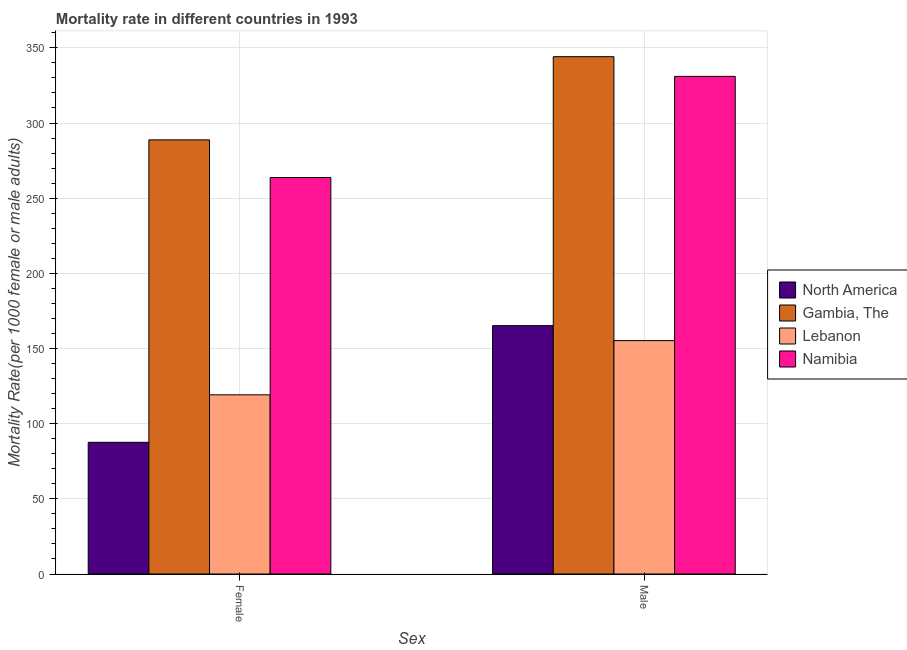How many different coloured bars are there?
Ensure brevity in your answer.  4. How many groups of bars are there?
Offer a terse response. 2. Are the number of bars on each tick of the X-axis equal?
Provide a short and direct response. Yes. How many bars are there on the 1st tick from the left?
Your answer should be very brief. 4. How many bars are there on the 1st tick from the right?
Your response must be concise. 4. What is the label of the 2nd group of bars from the left?
Ensure brevity in your answer.  Male. What is the male mortality rate in North America?
Give a very brief answer. 165.2. Across all countries, what is the maximum female mortality rate?
Provide a short and direct response. 288.79. Across all countries, what is the minimum male mortality rate?
Keep it short and to the point. 155.25. In which country was the female mortality rate maximum?
Give a very brief answer. Gambia, The. In which country was the male mortality rate minimum?
Your answer should be very brief. Lebanon. What is the total male mortality rate in the graph?
Your answer should be very brief. 995.58. What is the difference between the male mortality rate in North America and that in Gambia, The?
Make the answer very short. -178.91. What is the difference between the female mortality rate in Gambia, The and the male mortality rate in Namibia?
Your answer should be very brief. -42.23. What is the average female mortality rate per country?
Ensure brevity in your answer.  189.83. What is the difference between the female mortality rate and male mortality rate in Gambia, The?
Keep it short and to the point. -55.33. In how many countries, is the female mortality rate greater than 350 ?
Ensure brevity in your answer.  0. What is the ratio of the female mortality rate in Lebanon to that in Namibia?
Your response must be concise. 0.45. Is the male mortality rate in Namibia less than that in North America?
Offer a very short reply. No. In how many countries, is the female mortality rate greater than the average female mortality rate taken over all countries?
Your answer should be compact. 2. What does the 3rd bar from the left in Female represents?
Make the answer very short. Lebanon. What does the 1st bar from the right in Female represents?
Offer a very short reply. Namibia. Are all the bars in the graph horizontal?
Offer a very short reply. No. How many countries are there in the graph?
Your response must be concise. 4. What is the difference between two consecutive major ticks on the Y-axis?
Keep it short and to the point. 50. Does the graph contain any zero values?
Ensure brevity in your answer.  No. Does the graph contain grids?
Provide a short and direct response. Yes. What is the title of the graph?
Make the answer very short. Mortality rate in different countries in 1993. What is the label or title of the X-axis?
Provide a short and direct response. Sex. What is the label or title of the Y-axis?
Provide a short and direct response. Mortality Rate(per 1000 female or male adults). What is the Mortality Rate(per 1000 female or male adults) of North America in Female?
Ensure brevity in your answer.  87.6. What is the Mortality Rate(per 1000 female or male adults) of Gambia, The in Female?
Your response must be concise. 288.79. What is the Mortality Rate(per 1000 female or male adults) in Lebanon in Female?
Ensure brevity in your answer.  119.19. What is the Mortality Rate(per 1000 female or male adults) in Namibia in Female?
Make the answer very short. 263.75. What is the Mortality Rate(per 1000 female or male adults) of North America in Male?
Keep it short and to the point. 165.2. What is the Mortality Rate(per 1000 female or male adults) in Gambia, The in Male?
Your answer should be very brief. 344.12. What is the Mortality Rate(per 1000 female or male adults) in Lebanon in Male?
Make the answer very short. 155.25. What is the Mortality Rate(per 1000 female or male adults) in Namibia in Male?
Offer a terse response. 331.02. Across all Sex, what is the maximum Mortality Rate(per 1000 female or male adults) in North America?
Provide a succinct answer. 165.2. Across all Sex, what is the maximum Mortality Rate(per 1000 female or male adults) of Gambia, The?
Your response must be concise. 344.12. Across all Sex, what is the maximum Mortality Rate(per 1000 female or male adults) in Lebanon?
Your answer should be very brief. 155.25. Across all Sex, what is the maximum Mortality Rate(per 1000 female or male adults) in Namibia?
Make the answer very short. 331.02. Across all Sex, what is the minimum Mortality Rate(per 1000 female or male adults) in North America?
Your answer should be compact. 87.6. Across all Sex, what is the minimum Mortality Rate(per 1000 female or male adults) of Gambia, The?
Keep it short and to the point. 288.79. Across all Sex, what is the minimum Mortality Rate(per 1000 female or male adults) in Lebanon?
Your response must be concise. 119.19. Across all Sex, what is the minimum Mortality Rate(per 1000 female or male adults) in Namibia?
Your answer should be compact. 263.75. What is the total Mortality Rate(per 1000 female or male adults) in North America in the graph?
Offer a very short reply. 252.81. What is the total Mortality Rate(per 1000 female or male adults) of Gambia, The in the graph?
Your answer should be compact. 632.9. What is the total Mortality Rate(per 1000 female or male adults) in Lebanon in the graph?
Your answer should be compact. 274.43. What is the total Mortality Rate(per 1000 female or male adults) of Namibia in the graph?
Keep it short and to the point. 594.77. What is the difference between the Mortality Rate(per 1000 female or male adults) of North America in Female and that in Male?
Ensure brevity in your answer.  -77.6. What is the difference between the Mortality Rate(per 1000 female or male adults) in Gambia, The in Female and that in Male?
Offer a very short reply. -55.33. What is the difference between the Mortality Rate(per 1000 female or male adults) of Lebanon in Female and that in Male?
Your response must be concise. -36.06. What is the difference between the Mortality Rate(per 1000 female or male adults) in Namibia in Female and that in Male?
Give a very brief answer. -67.27. What is the difference between the Mortality Rate(per 1000 female or male adults) in North America in Female and the Mortality Rate(per 1000 female or male adults) in Gambia, The in Male?
Provide a short and direct response. -256.51. What is the difference between the Mortality Rate(per 1000 female or male adults) of North America in Female and the Mortality Rate(per 1000 female or male adults) of Lebanon in Male?
Your response must be concise. -67.64. What is the difference between the Mortality Rate(per 1000 female or male adults) of North America in Female and the Mortality Rate(per 1000 female or male adults) of Namibia in Male?
Make the answer very short. -243.42. What is the difference between the Mortality Rate(per 1000 female or male adults) in Gambia, The in Female and the Mortality Rate(per 1000 female or male adults) in Lebanon in Male?
Provide a succinct answer. 133.54. What is the difference between the Mortality Rate(per 1000 female or male adults) in Gambia, The in Female and the Mortality Rate(per 1000 female or male adults) in Namibia in Male?
Provide a succinct answer. -42.23. What is the difference between the Mortality Rate(per 1000 female or male adults) in Lebanon in Female and the Mortality Rate(per 1000 female or male adults) in Namibia in Male?
Give a very brief answer. -211.83. What is the average Mortality Rate(per 1000 female or male adults) of North America per Sex?
Provide a short and direct response. 126.4. What is the average Mortality Rate(per 1000 female or male adults) in Gambia, The per Sex?
Provide a succinct answer. 316.45. What is the average Mortality Rate(per 1000 female or male adults) in Lebanon per Sex?
Ensure brevity in your answer.  137.22. What is the average Mortality Rate(per 1000 female or male adults) in Namibia per Sex?
Provide a succinct answer. 297.38. What is the difference between the Mortality Rate(per 1000 female or male adults) of North America and Mortality Rate(per 1000 female or male adults) of Gambia, The in Female?
Your response must be concise. -201.19. What is the difference between the Mortality Rate(per 1000 female or male adults) in North America and Mortality Rate(per 1000 female or male adults) in Lebanon in Female?
Make the answer very short. -31.59. What is the difference between the Mortality Rate(per 1000 female or male adults) in North America and Mortality Rate(per 1000 female or male adults) in Namibia in Female?
Your answer should be compact. -176.15. What is the difference between the Mortality Rate(per 1000 female or male adults) of Gambia, The and Mortality Rate(per 1000 female or male adults) of Lebanon in Female?
Your answer should be very brief. 169.6. What is the difference between the Mortality Rate(per 1000 female or male adults) of Gambia, The and Mortality Rate(per 1000 female or male adults) of Namibia in Female?
Offer a very short reply. 25.04. What is the difference between the Mortality Rate(per 1000 female or male adults) in Lebanon and Mortality Rate(per 1000 female or male adults) in Namibia in Female?
Give a very brief answer. -144.56. What is the difference between the Mortality Rate(per 1000 female or male adults) in North America and Mortality Rate(per 1000 female or male adults) in Gambia, The in Male?
Your answer should be very brief. -178.91. What is the difference between the Mortality Rate(per 1000 female or male adults) of North America and Mortality Rate(per 1000 female or male adults) of Lebanon in Male?
Provide a short and direct response. 9.96. What is the difference between the Mortality Rate(per 1000 female or male adults) of North America and Mortality Rate(per 1000 female or male adults) of Namibia in Male?
Give a very brief answer. -165.81. What is the difference between the Mortality Rate(per 1000 female or male adults) in Gambia, The and Mortality Rate(per 1000 female or male adults) in Lebanon in Male?
Ensure brevity in your answer.  188.87. What is the difference between the Mortality Rate(per 1000 female or male adults) in Gambia, The and Mortality Rate(per 1000 female or male adults) in Namibia in Male?
Ensure brevity in your answer.  13.1. What is the difference between the Mortality Rate(per 1000 female or male adults) in Lebanon and Mortality Rate(per 1000 female or male adults) in Namibia in Male?
Offer a terse response. -175.77. What is the ratio of the Mortality Rate(per 1000 female or male adults) of North America in Female to that in Male?
Keep it short and to the point. 0.53. What is the ratio of the Mortality Rate(per 1000 female or male adults) in Gambia, The in Female to that in Male?
Make the answer very short. 0.84. What is the ratio of the Mortality Rate(per 1000 female or male adults) of Lebanon in Female to that in Male?
Your response must be concise. 0.77. What is the ratio of the Mortality Rate(per 1000 female or male adults) in Namibia in Female to that in Male?
Make the answer very short. 0.8. What is the difference between the highest and the second highest Mortality Rate(per 1000 female or male adults) in North America?
Your answer should be very brief. 77.6. What is the difference between the highest and the second highest Mortality Rate(per 1000 female or male adults) in Gambia, The?
Offer a terse response. 55.33. What is the difference between the highest and the second highest Mortality Rate(per 1000 female or male adults) in Lebanon?
Make the answer very short. 36.06. What is the difference between the highest and the second highest Mortality Rate(per 1000 female or male adults) of Namibia?
Provide a short and direct response. 67.27. What is the difference between the highest and the lowest Mortality Rate(per 1000 female or male adults) of North America?
Your response must be concise. 77.6. What is the difference between the highest and the lowest Mortality Rate(per 1000 female or male adults) in Gambia, The?
Provide a short and direct response. 55.33. What is the difference between the highest and the lowest Mortality Rate(per 1000 female or male adults) in Lebanon?
Offer a very short reply. 36.06. What is the difference between the highest and the lowest Mortality Rate(per 1000 female or male adults) in Namibia?
Offer a terse response. 67.27. 